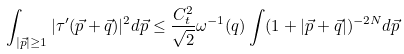<formula> <loc_0><loc_0><loc_500><loc_500>\int _ { | \vec { p } | \geq 1 } | \tau ^ { \prime } ( \vec { p } + \vec { q } ) | ^ { 2 } d \vec { p } \leq \frac { C _ { t } ^ { 2 } } { \sqrt { 2 } } \omega ^ { - 1 } ( q ) \int ( 1 + | \vec { p } + \vec { q } | ) ^ { - 2 N } d \vec { p }</formula> 